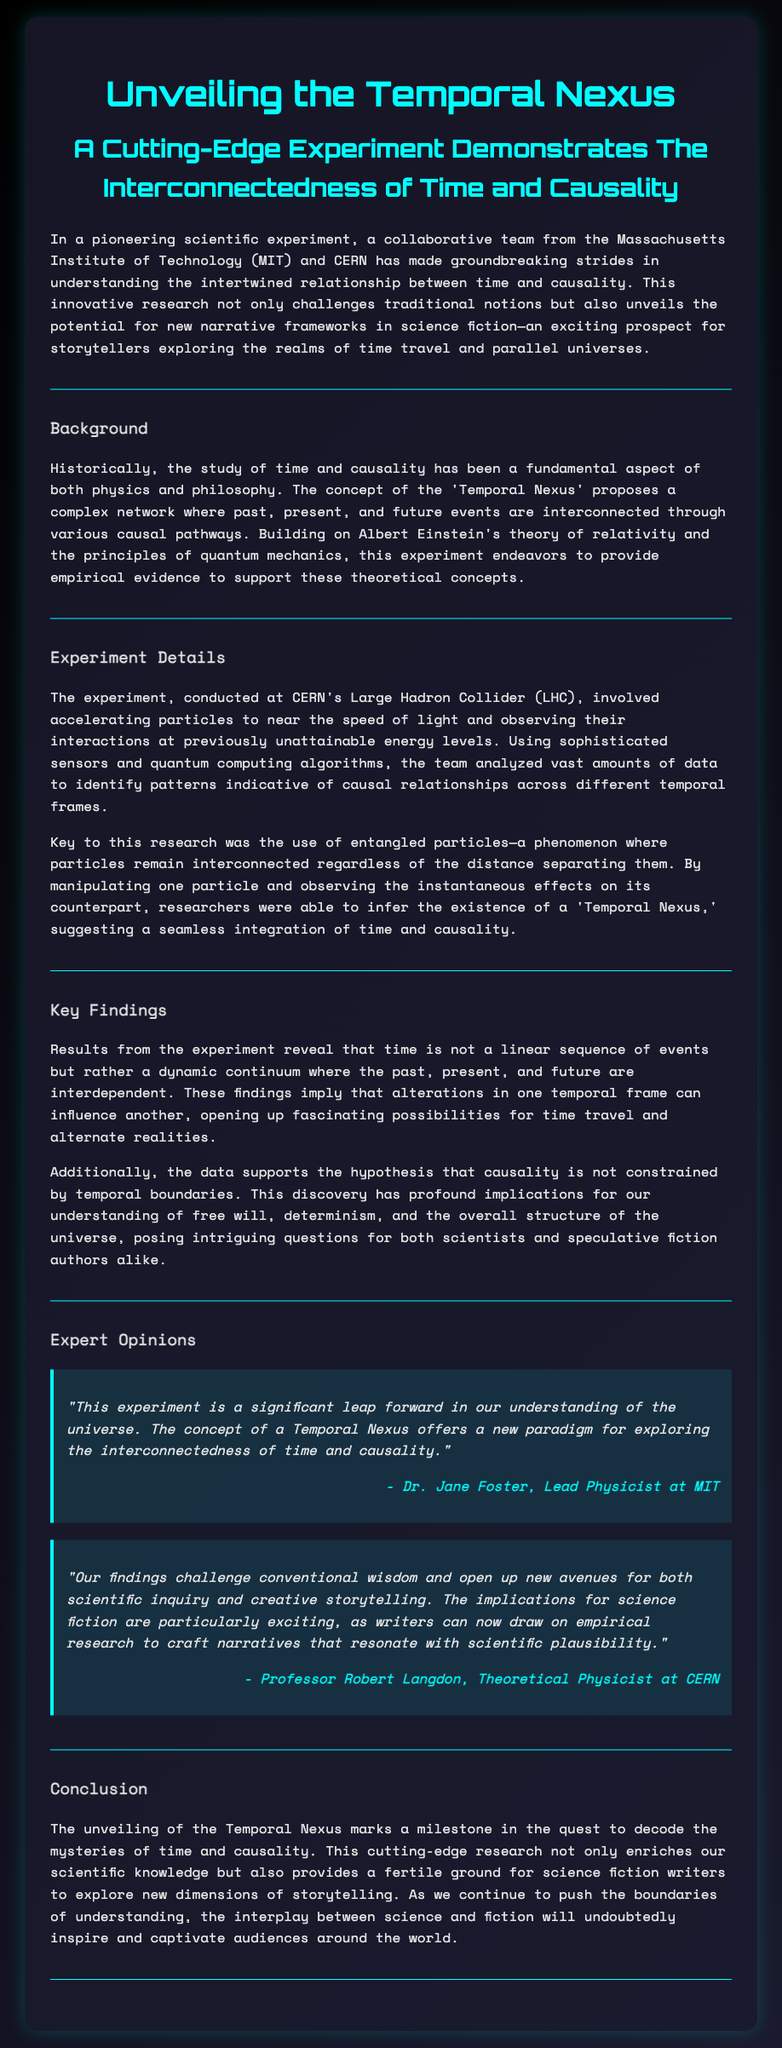What is the title of the press release? The title of the press release is a prominent heading that reflects the main topic and can be found at the top of the document.
Answer: Unveiling the Temporal Nexus: A Cutting-Edge Experiment Demonstrates The Interconnectedness of Time and Causality Who is the lead physicist at MIT? The document names Dr. Jane Foster as the lead physicist, specifically mentioned in the expert opinions section.
Answer: Dr. Jane Foster What institution collaborated with MIT on this experiment? The text mentions CERN as the collaborating institution in the groundbreaking scientific experiment.
Answer: CERN What concept does the 'Temporal Nexus' propose? The document explains that the 'Temporal Nexus' proposes a complex network where past, present, and future events are interconnected.
Answer: Complex network What phenomenon was key to this research? The key phenomenon mentioned in the experiment details is entangled particles, which are crucial for understanding causal relationships.
Answer: Entangled particles According to the findings, what is time described as? The findings in the experiment suggest a new perspective on time that contrasts with conventional views and is stated in the key findings section.
Answer: Dynamic continuum What department does Professor Robert Langdon belong to? The document attributes Professor Robert Langdon to CERN as a theoretical physicist, providing context to his expert opinion.
Answer: Theoretical Physicist What milestone does the conclusion of the press release mention? The conclusion emphasizes the significance of the unveiling of the Temporal Nexus as a milestone in scientific understanding.
Answer: Milestone 